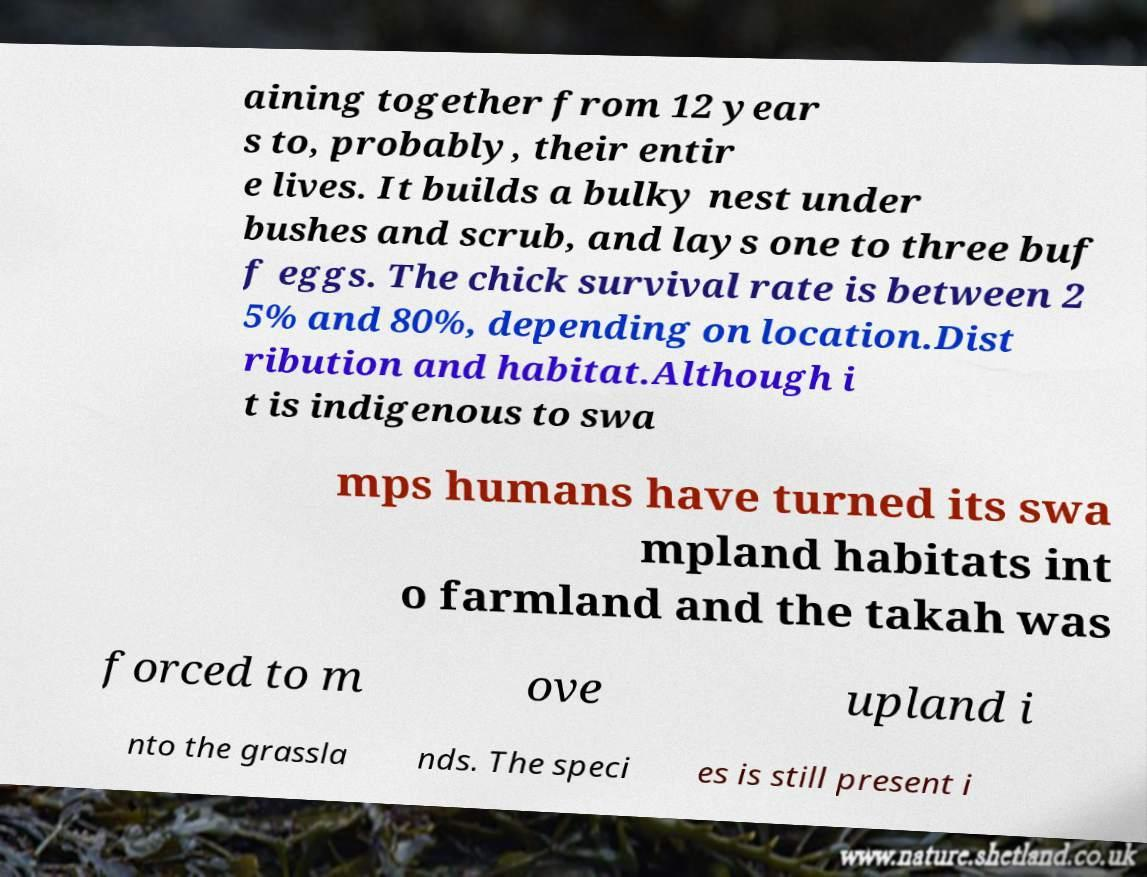What messages or text are displayed in this image? I need them in a readable, typed format. aining together from 12 year s to, probably, their entir e lives. It builds a bulky nest under bushes and scrub, and lays one to three buf f eggs. The chick survival rate is between 2 5% and 80%, depending on location.Dist ribution and habitat.Although i t is indigenous to swa mps humans have turned its swa mpland habitats int o farmland and the takah was forced to m ove upland i nto the grassla nds. The speci es is still present i 